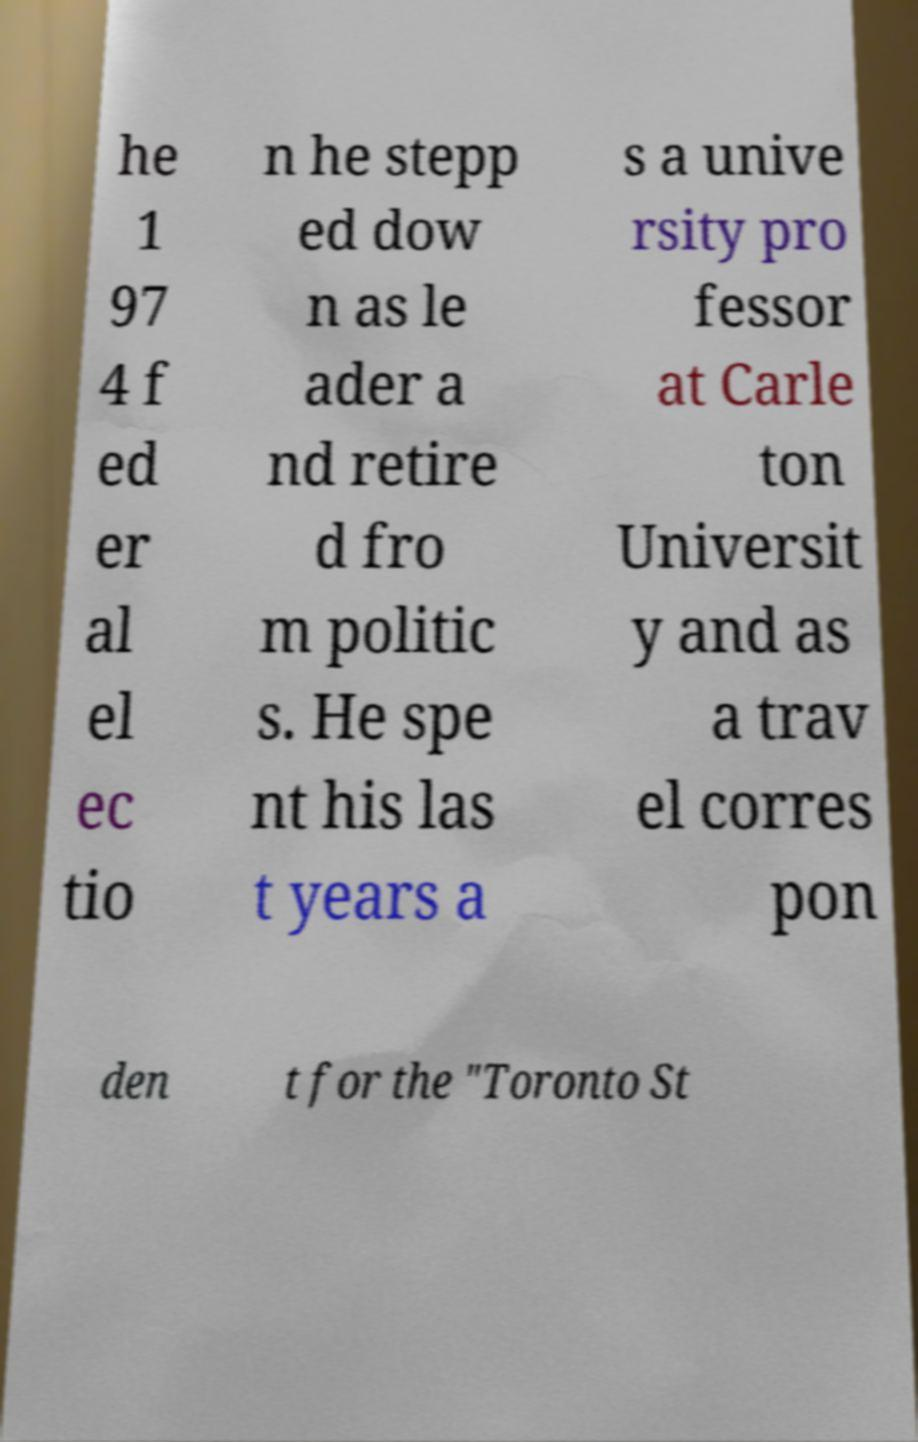I need the written content from this picture converted into text. Can you do that? he 1 97 4 f ed er al el ec tio n he stepp ed dow n as le ader a nd retire d fro m politic s. He spe nt his las t years a s a unive rsity pro fessor at Carle ton Universit y and as a trav el corres pon den t for the "Toronto St 